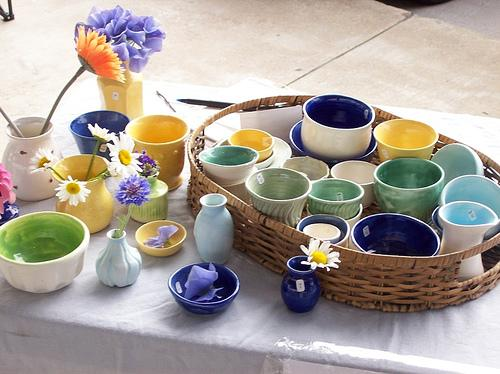How many of the vases are made from something other than glass? Please explain your reasoning. two. Other vases are made from pottery and are different shapes. 